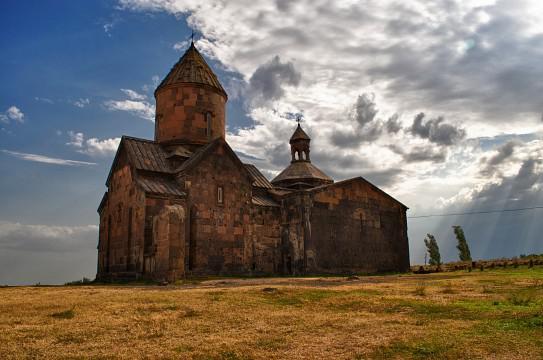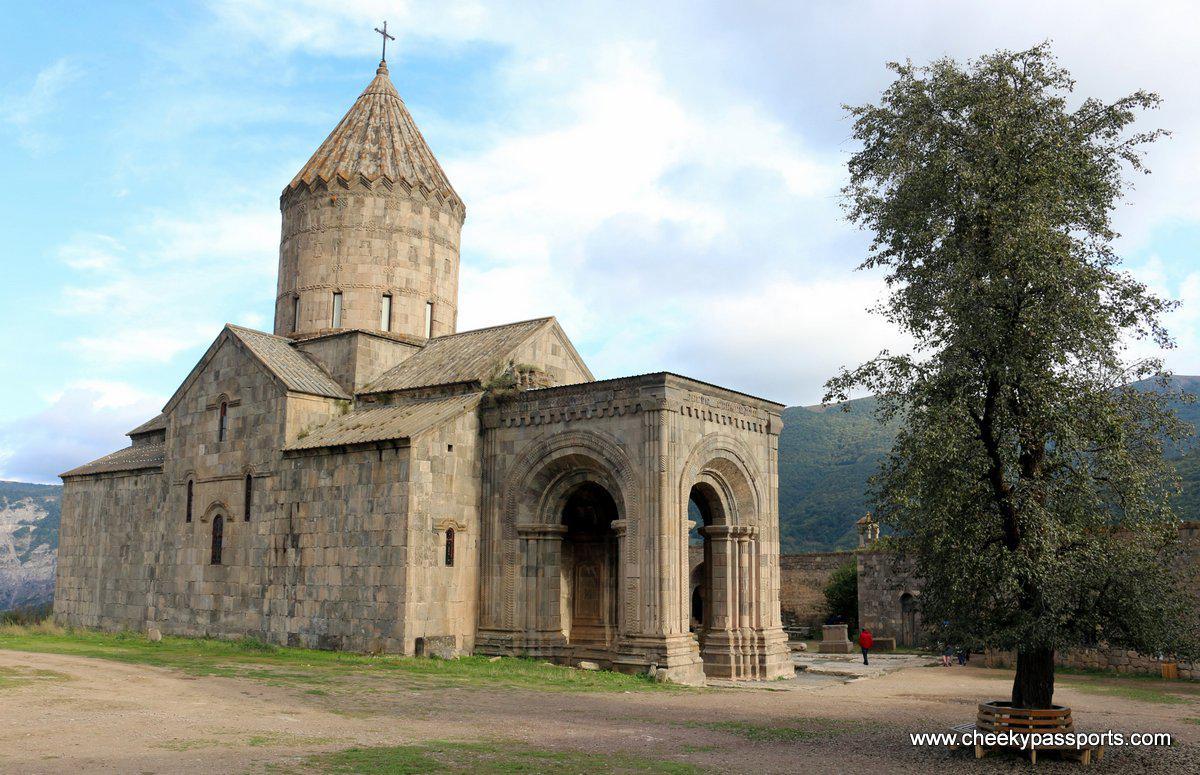The first image is the image on the left, the second image is the image on the right. For the images shown, is this caption "The left and right image contains the same number of churches with a round dome and a cross at the top." true? Answer yes or no. Yes. 